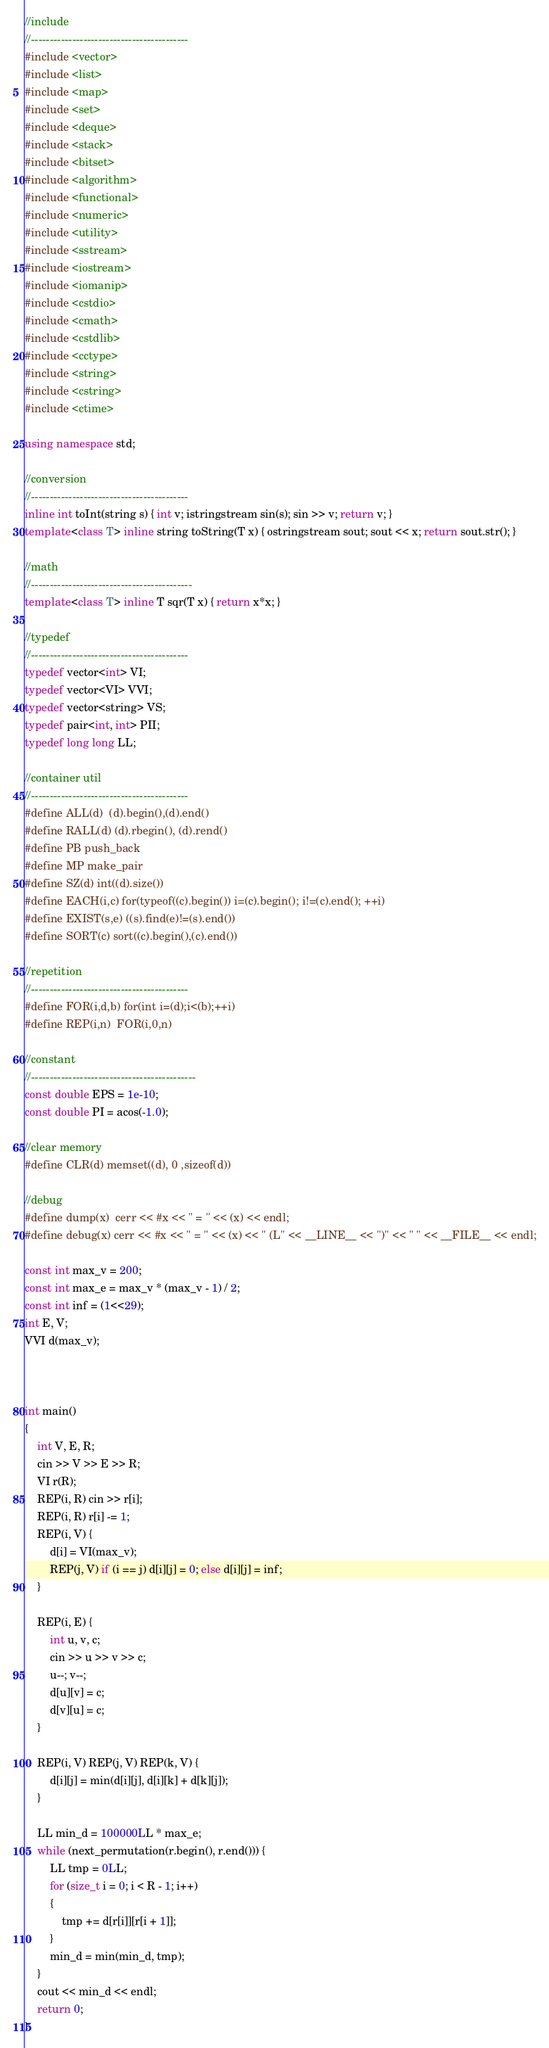Convert code to text. <code><loc_0><loc_0><loc_500><loc_500><_C++_>//include
//------------------------------------------
#include <vector>
#include <list>
#include <map>
#include <set>
#include <deque>
#include <stack>
#include <bitset>
#include <algorithm>
#include <functional>
#include <numeric>
#include <utility>
#include <sstream>
#include <iostream>
#include <iomanip>
#include <cstdio>
#include <cmath>
#include <cstdlib>
#include <cctype>
#include <string>
#include <cstring>
#include <ctime>

using namespace std;

//conversion
//------------------------------------------
inline int toInt(string s) { int v; istringstream sin(s); sin >> v; return v; }
template<class T> inline string toString(T x) { ostringstream sout; sout << x; return sout.str(); }

//math
//-------------------------------------------
template<class T> inline T sqr(T x) { return x*x; }

//typedef
//------------------------------------------
typedef vector<int> VI;
typedef vector<VI> VVI;
typedef vector<string> VS;
typedef pair<int, int> PII;
typedef long long LL;

//container util
//------------------------------------------
#define ALL(d)  (d).begin(),(d).end()
#define RALL(d) (d).rbegin(), (d).rend()
#define PB push_back
#define MP make_pair
#define SZ(d) int((d).size())
#define EACH(i,c) for(typeof((c).begin()) i=(c).begin(); i!=(c).end(); ++i)
#define EXIST(s,e) ((s).find(e)!=(s).end())
#define SORT(c) sort((c).begin(),(c).end())

//repetition
//------------------------------------------
#define FOR(i,d,b) for(int i=(d);i<(b);++i)
#define REP(i,n)  FOR(i,0,n)

//constant
//--------------------------------------------
const double EPS = 1e-10;
const double PI = acos(-1.0);

//clear memory
#define CLR(d) memset((d), 0 ,sizeof(d))

//debug
#define dump(x)  cerr << #x << " = " << (x) << endl;
#define debug(x) cerr << #x << " = " << (x) << " (L" << __LINE__ << ")" << " " << __FILE__ << endl;

const int max_v = 200;
const int max_e = max_v * (max_v - 1) / 2;
const int inf = (1<<29);
int E, V;
VVI d(max_v);



int main()
{
	int V, E, R;
	cin >> V >> E >> R;
	VI r(R);
	REP(i, R) cin >> r[i];
	REP(i, R) r[i] -= 1;
	REP(i, V) {
		d[i] = VI(max_v);
		REP(j, V) if (i == j) d[i][j] = 0; else d[i][j] = inf;
	}

	REP(i, E) {
		int u, v, c;
		cin >> u >> v >> c;
		u--; v--;
		d[u][v] = c; 
		d[v][u] = c;
	}

	REP(i, V) REP(j, V) REP(k, V) {
		d[i][j] = min(d[i][j], d[i][k] + d[k][j]);
	}

	LL min_d = 100000LL * max_e;
	while (next_permutation(r.begin(), r.end())) {
		LL tmp = 0LL;
		for (size_t i = 0; i < R - 1; i++)
		{
			tmp += d[r[i]][r[i + 1]];
		}
		min_d = min(min_d, tmp);
	}
	cout << min_d << endl;
	return 0;
}</code> 